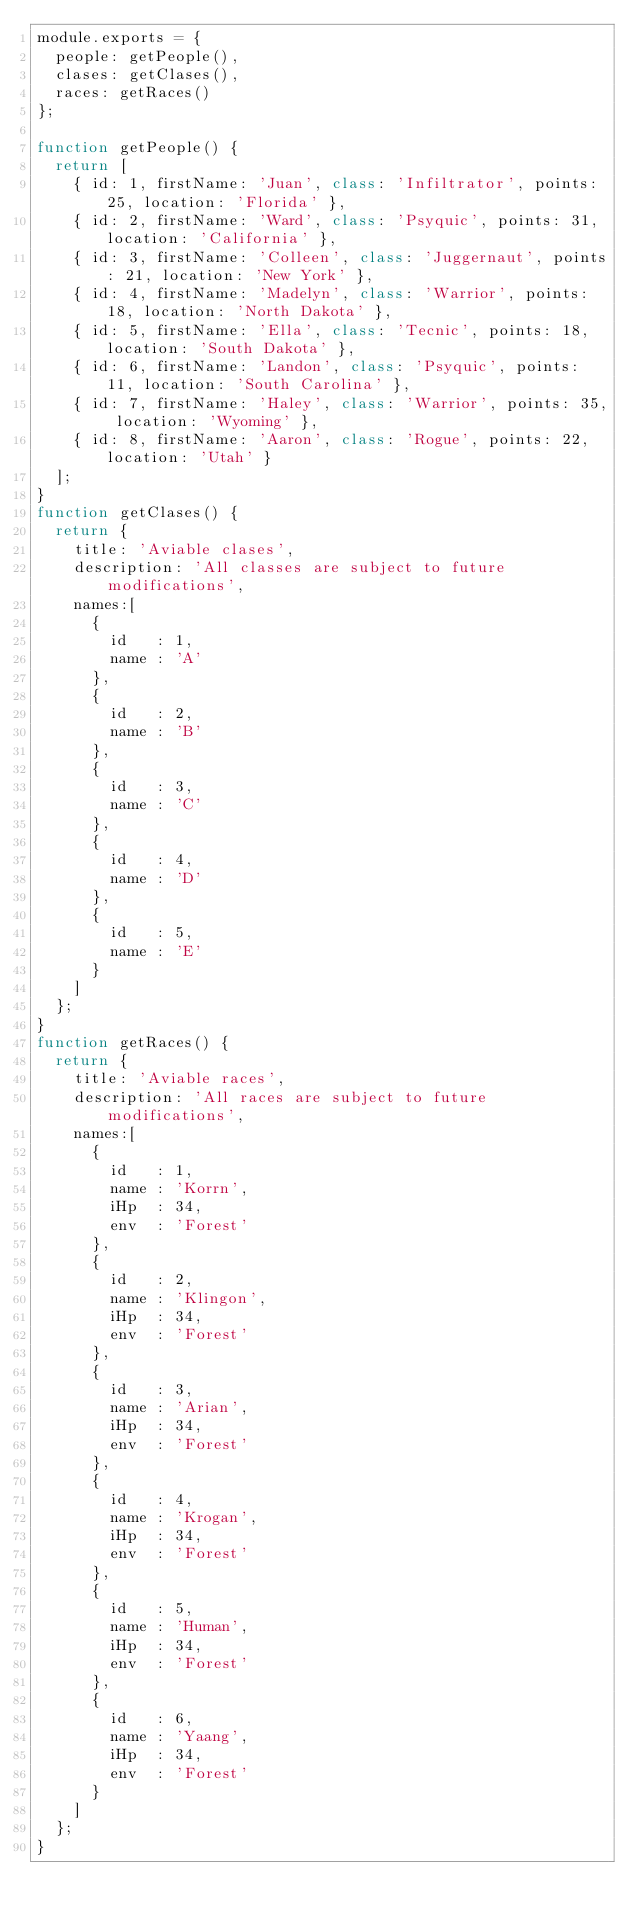Convert code to text. <code><loc_0><loc_0><loc_500><loc_500><_JavaScript_>module.exports = {
  people: getPeople(),
  clases: getClases(),
  races: getRaces()
};

function getPeople() {
  return [
    { id: 1, firstName: 'Juan', class: 'Infiltrator', points: 25, location: 'Florida' },
    { id: 2, firstName: 'Ward', class: 'Psyquic', points: 31, location: 'California' },
    { id: 3, firstName: 'Colleen', class: 'Juggernaut', points: 21, location: 'New York' },
    { id: 4, firstName: 'Madelyn', class: 'Warrior', points: 18, location: 'North Dakota' },
    { id: 5, firstName: 'Ella', class: 'Tecnic', points: 18, location: 'South Dakota' },
    { id: 6, firstName: 'Landon', class: 'Psyquic', points: 11, location: 'South Carolina' },
    { id: 7, firstName: 'Haley', class: 'Warrior', points: 35, location: 'Wyoming' },
    { id: 8, firstName: 'Aaron', class: 'Rogue', points: 22, location: 'Utah' }
  ];
}
function getClases() {
  return {
    title: 'Aviable clases',
    description: 'All classes are subject to future modifications',
    names:[
      {
        id   : 1,
        name : 'A'
      },
      {
        id   : 2,
        name : 'B'
      },
      {
        id   : 3,
        name : 'C'
      },
      {
        id   : 4,
        name : 'D'
      },
      {
        id   : 5,
        name : 'E'
      }
    ]
  };
}
function getRaces() {
  return {
    title: 'Aviable races',
    description: 'All races are subject to future modifications',
    names:[
      {
        id   : 1,
        name : 'Korrn',
        iHp  : 34,
        env  : 'Forest'
      },
      {
        id   : 2,
        name : 'Klingon',
        iHp  : 34,
        env  : 'Forest'
      },
      {
        id   : 3,
        name : 'Arian',
        iHp  : 34,
        env  : 'Forest'
      },
      {
        id   : 4,
        name : 'Krogan',
        iHp  : 34,
        env  : 'Forest'
      },
      {
        id   : 5,
        name : 'Human',
        iHp  : 34,
        env  : 'Forest'
      },
      {
        id   : 6,
        name : 'Yaang',
        iHp  : 34,
        env  : 'Forest'
      }
    ]
  };
}
</code> 